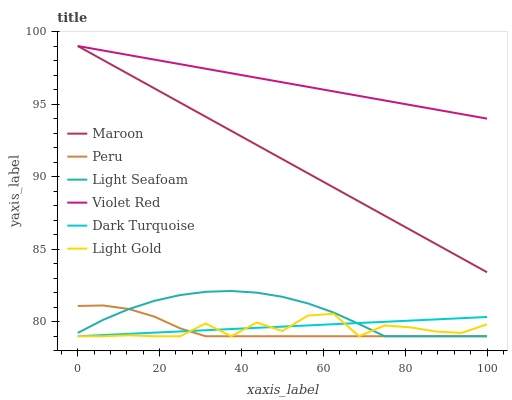Does Dark Turquoise have the minimum area under the curve?
Answer yes or no. No. Does Dark Turquoise have the maximum area under the curve?
Answer yes or no. No. Is Dark Turquoise the smoothest?
Answer yes or no. No. Is Dark Turquoise the roughest?
Answer yes or no. No. Does Maroon have the lowest value?
Answer yes or no. No. Does Dark Turquoise have the highest value?
Answer yes or no. No. Is Peru less than Violet Red?
Answer yes or no. Yes. Is Maroon greater than Light Gold?
Answer yes or no. Yes. Does Peru intersect Violet Red?
Answer yes or no. No. 